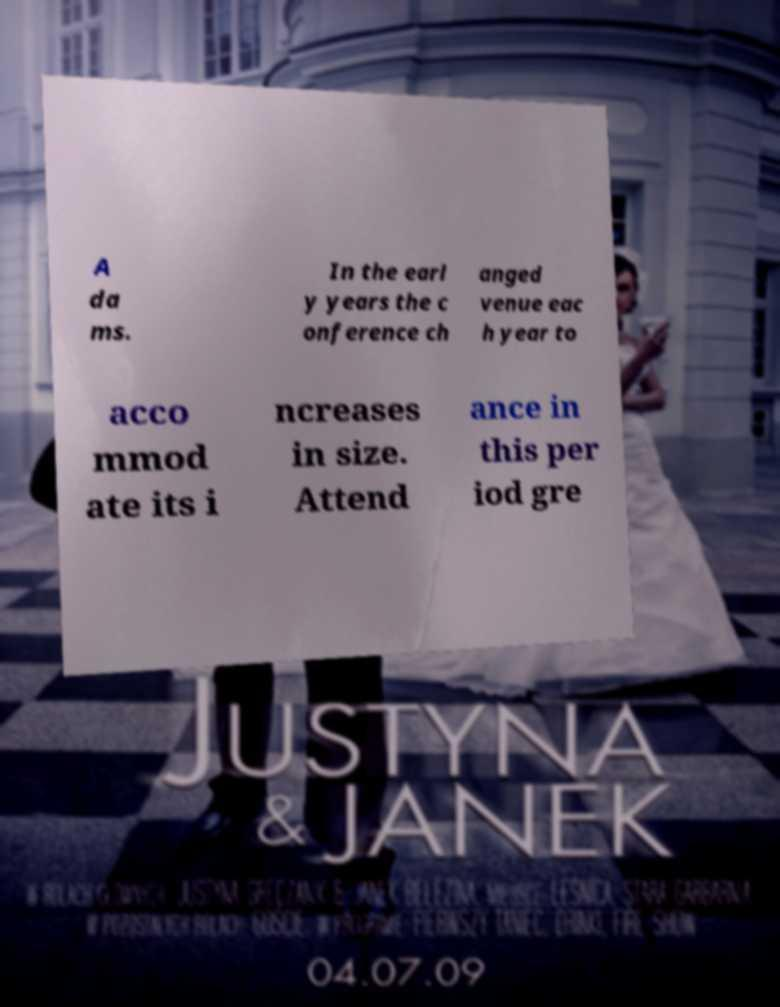There's text embedded in this image that I need extracted. Can you transcribe it verbatim? A da ms. In the earl y years the c onference ch anged venue eac h year to acco mmod ate its i ncreases in size. Attend ance in this per iod gre 